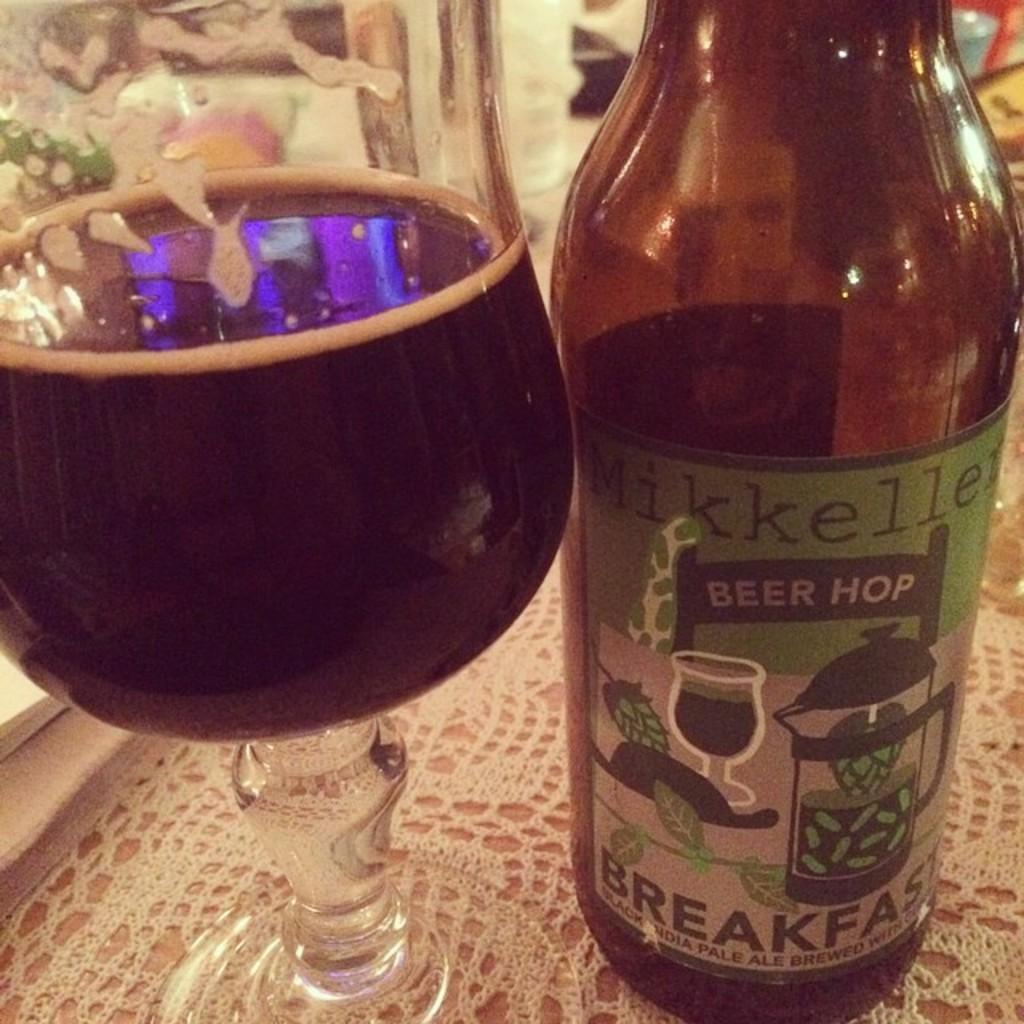Provide a one-sentence caption for the provided image. a bottle and glass of Mikkellen Beer Hop pale ale. 